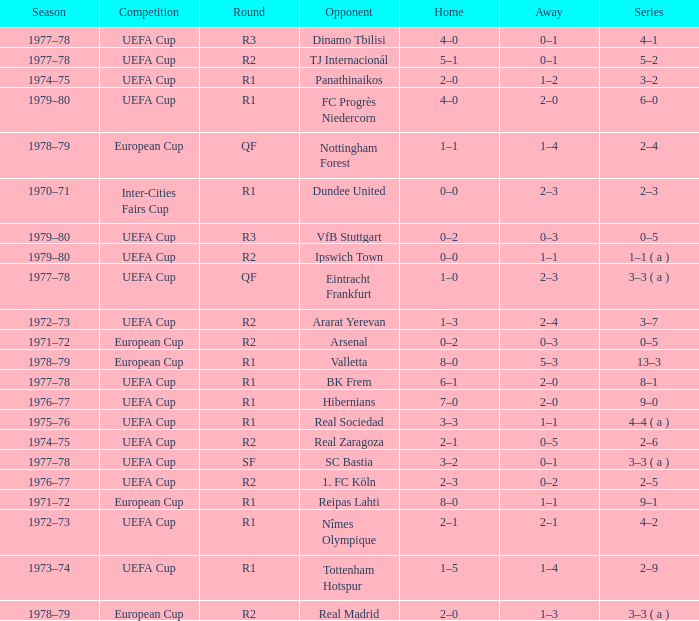Which Home has a Round of r1, and an Opponent of dundee united? 0–0. 